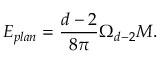Convert formula to latex. <formula><loc_0><loc_0><loc_500><loc_500>E _ { p l a n } = \frac { d - 2 } { 8 \pi } \Omega _ { d - 2 } M .</formula> 